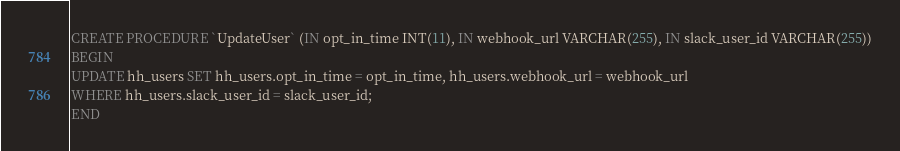<code> <loc_0><loc_0><loc_500><loc_500><_SQL_>CREATE PROCEDURE `UpdateUser` (IN opt_in_time INT(11), IN webhook_url VARCHAR(255), IN slack_user_id VARCHAR(255))
BEGIN
UPDATE hh_users SET hh_users.opt_in_time = opt_in_time, hh_users.webhook_url = webhook_url
WHERE hh_users.slack_user_id = slack_user_id;
END

</code> 